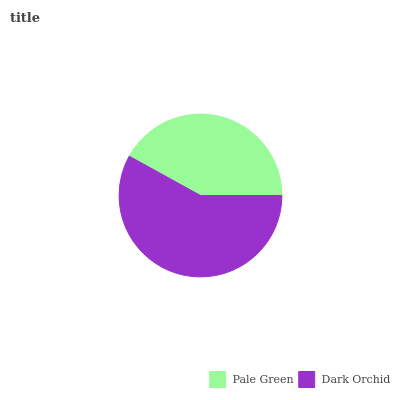Is Pale Green the minimum?
Answer yes or no. Yes. Is Dark Orchid the maximum?
Answer yes or no. Yes. Is Dark Orchid the minimum?
Answer yes or no. No. Is Dark Orchid greater than Pale Green?
Answer yes or no. Yes. Is Pale Green less than Dark Orchid?
Answer yes or no. Yes. Is Pale Green greater than Dark Orchid?
Answer yes or no. No. Is Dark Orchid less than Pale Green?
Answer yes or no. No. Is Dark Orchid the high median?
Answer yes or no. Yes. Is Pale Green the low median?
Answer yes or no. Yes. Is Pale Green the high median?
Answer yes or no. No. Is Dark Orchid the low median?
Answer yes or no. No. 